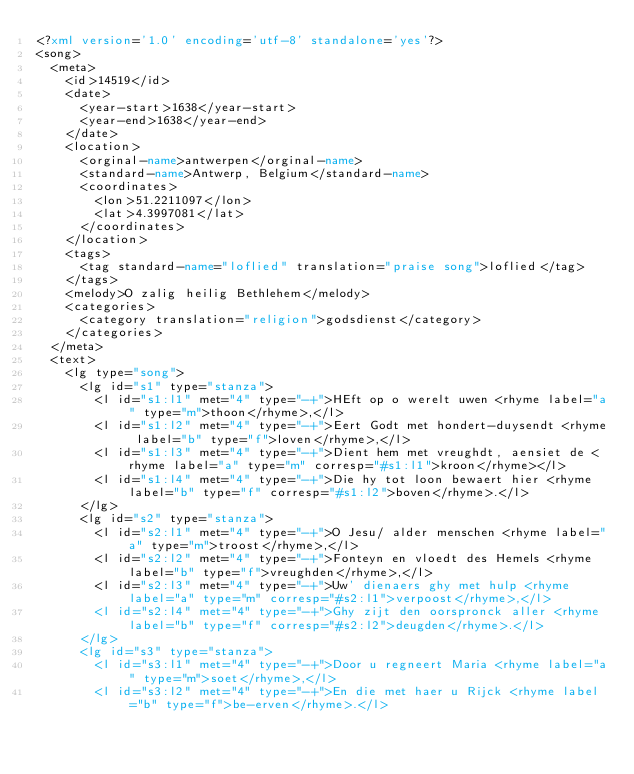<code> <loc_0><loc_0><loc_500><loc_500><_XML_><?xml version='1.0' encoding='utf-8' standalone='yes'?>
<song>
  <meta>
    <id>14519</id>
    <date>
      <year-start>1638</year-start>
      <year-end>1638</year-end>
    </date>
    <location>
      <orginal-name>antwerpen</orginal-name>
      <standard-name>Antwerp, Belgium</standard-name>
      <coordinates>
        <lon>51.2211097</lon>
        <lat>4.3997081</lat>
      </coordinates>
    </location>
    <tags>
      <tag standard-name="loflied" translation="praise song">loflied</tag>
    </tags>
    <melody>O zalig heilig Bethlehem</melody>
    <categories>
      <category translation="religion">godsdienst</category>
    </categories>
  </meta>
  <text>
    <lg type="song">
      <lg id="s1" type="stanza">
        <l id="s1:l1" met="4" type="-+">HEft op o werelt uwen <rhyme label="a" type="m">thoon</rhyme>,</l>
        <l id="s1:l2" met="4" type="-+">Eert Godt met hondert-duysendt <rhyme label="b" type="f">loven</rhyme>,</l>
        <l id="s1:l3" met="4" type="-+">Dient hem met vreughdt, aensiet de <rhyme label="a" type="m" corresp="#s1:l1">kroon</rhyme></l>
        <l id="s1:l4" met="4" type="-+">Die hy tot loon bewaert hier <rhyme label="b" type="f" corresp="#s1:l2">boven</rhyme>.</l>
      </lg>
      <lg id="s2" type="stanza">
        <l id="s2:l1" met="4" type="-+">O Jesu/ alder menschen <rhyme label="a" type="m">troost</rhyme>,</l>
        <l id="s2:l2" met="4" type="-+">Fonteyn en vloedt des Hemels <rhyme label="b" type="f">vreughden</rhyme>,</l>
        <l id="s2:l3" met="4" type="-+">Uw' dienaers ghy met hulp <rhyme label="a" type="m" corresp="#s2:l1">verpoost</rhyme>,</l>
        <l id="s2:l4" met="4" type="-+">Ghy zijt den oorspronck aller <rhyme label="b" type="f" corresp="#s2:l2">deugden</rhyme>.</l>
      </lg>
      <lg id="s3" type="stanza">
        <l id="s3:l1" met="4" type="-+">Door u regneert Maria <rhyme label="a" type="m">soet</rhyme>,</l>
        <l id="s3:l2" met="4" type="-+">En die met haer u Rijck <rhyme label="b" type="f">be-erven</rhyme>.</l></code> 